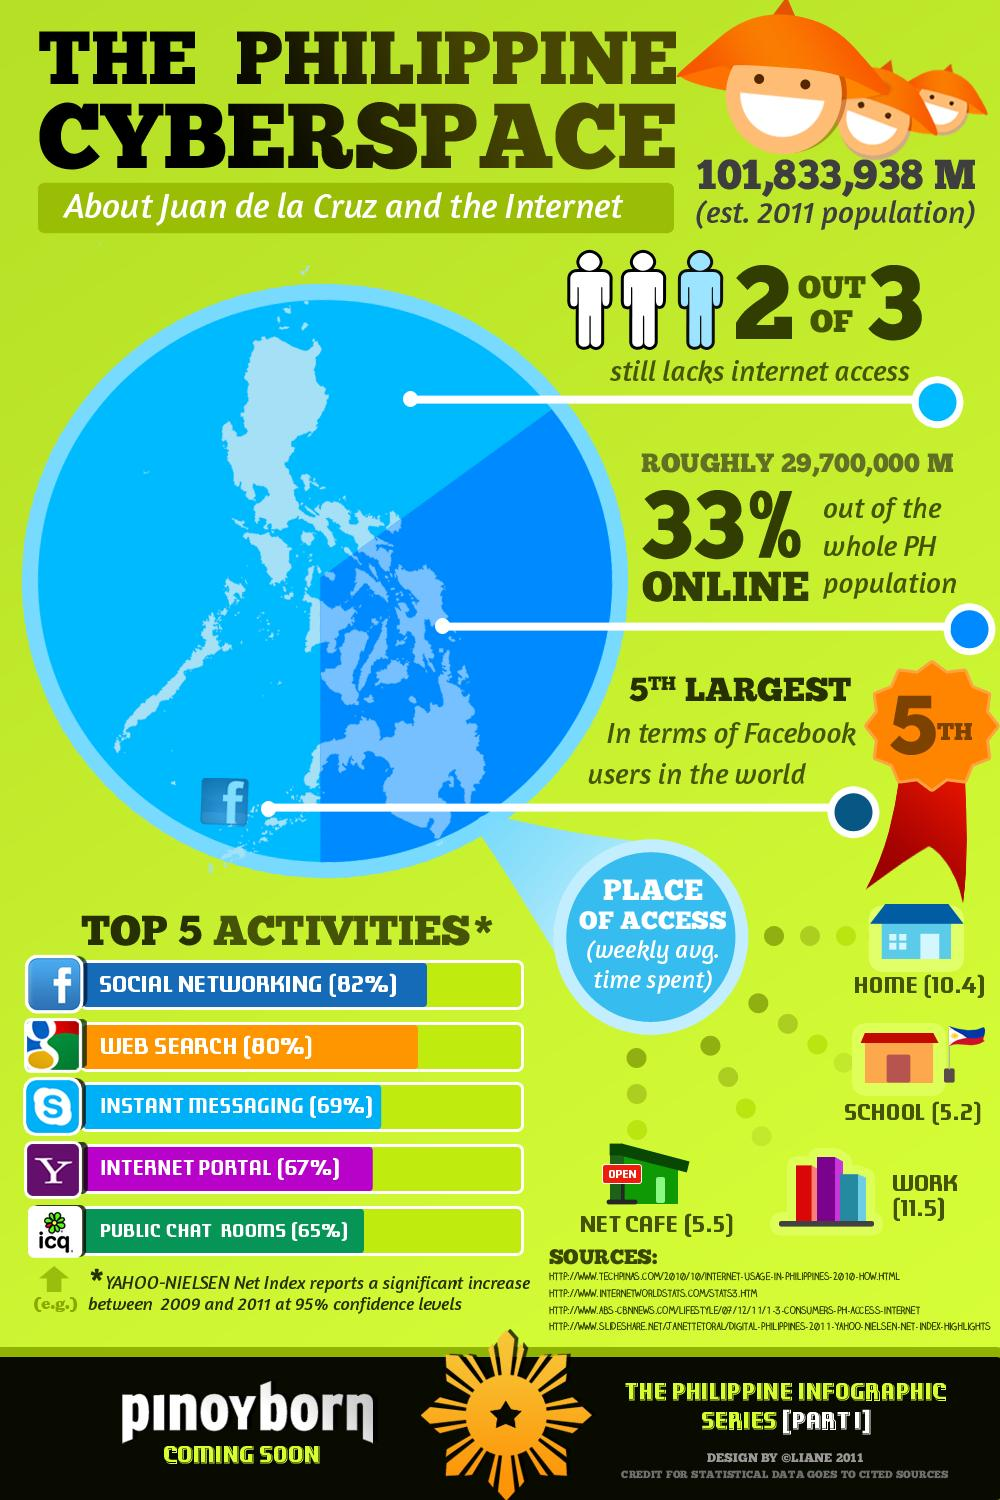Outline some significant characteristics in this image. The place that shows the highest weekly average time spent is work. The weekly average time spent on access is lowest in school. According to estimates, approximately 67% of the population does not have access to the internet. The second most commonly used internet activity is web search. 